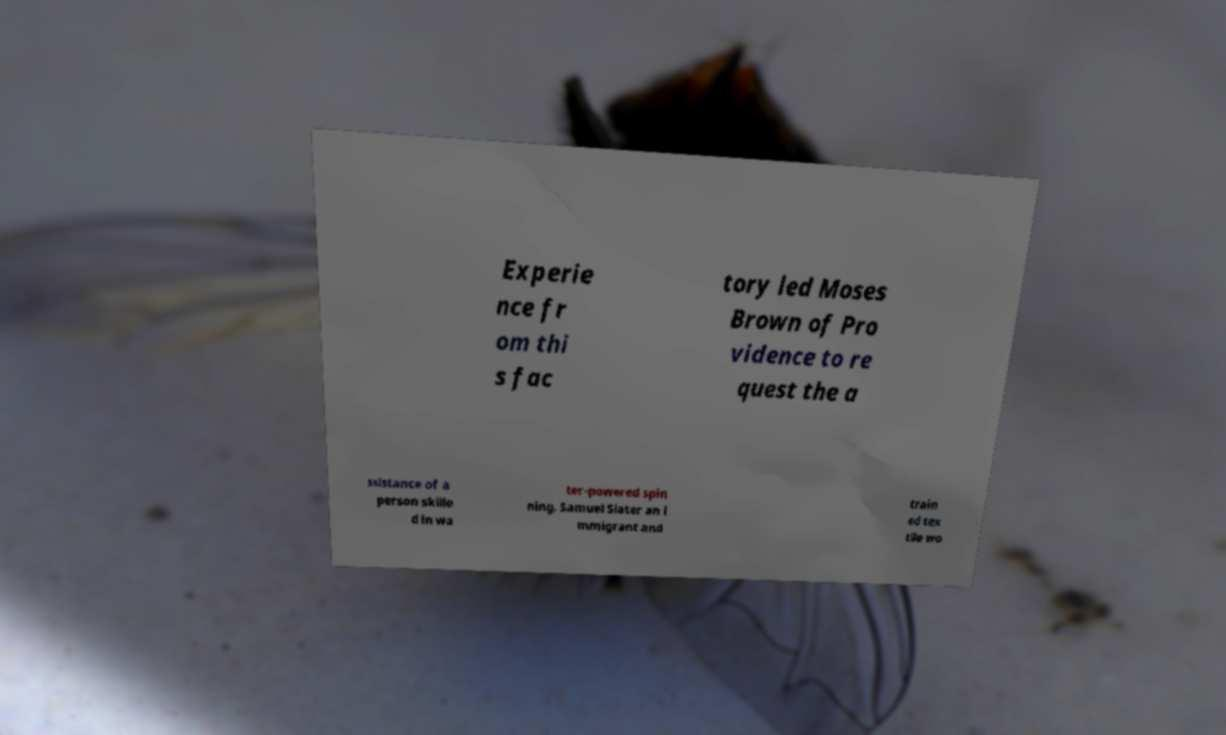Please identify and transcribe the text found in this image. Experie nce fr om thi s fac tory led Moses Brown of Pro vidence to re quest the a ssistance of a person skille d in wa ter-powered spin ning. Samuel Slater an i mmigrant and train ed tex tile wo 